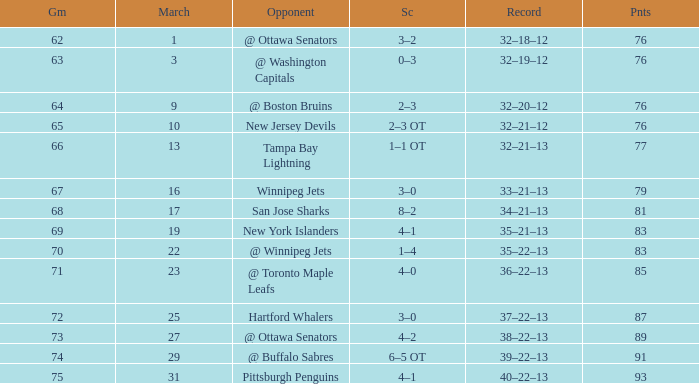Which Game is the lowest one that has a Score of 2–3 ot, and Points larger than 76? None. 